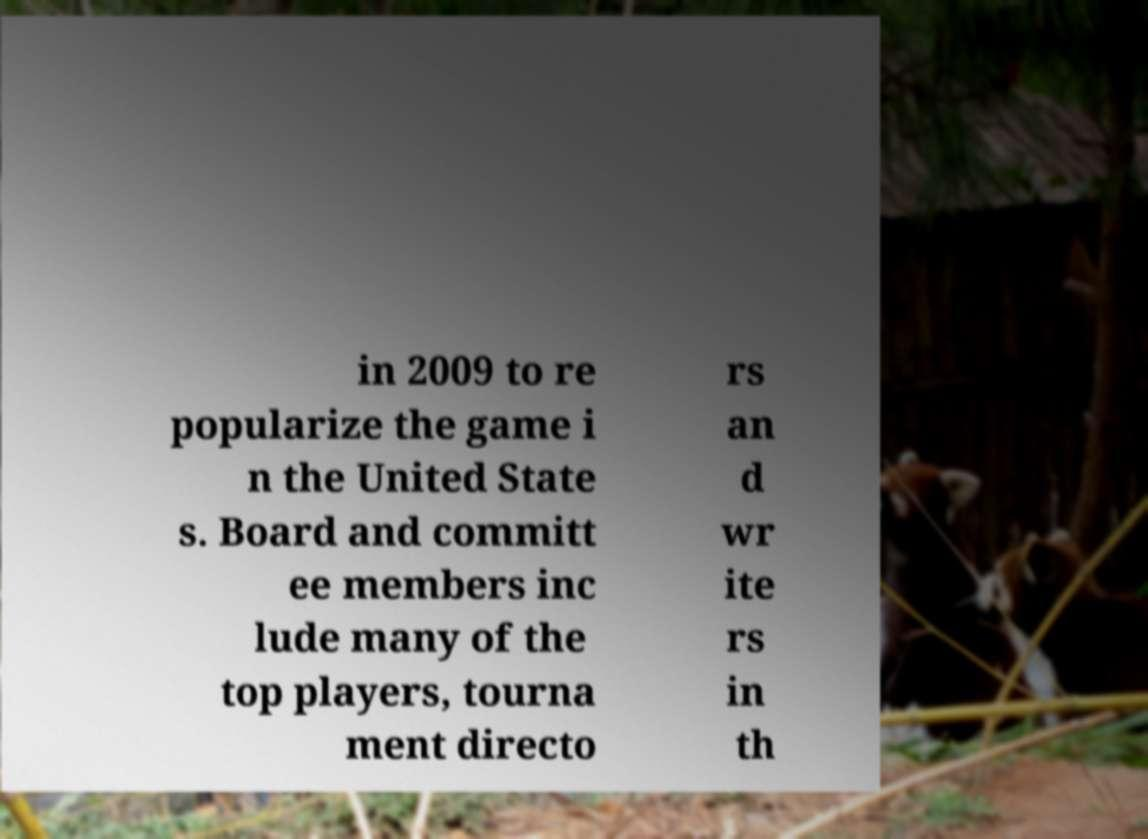Could you assist in decoding the text presented in this image and type it out clearly? in 2009 to re popularize the game i n the United State s. Board and committ ee members inc lude many of the top players, tourna ment directo rs an d wr ite rs in th 